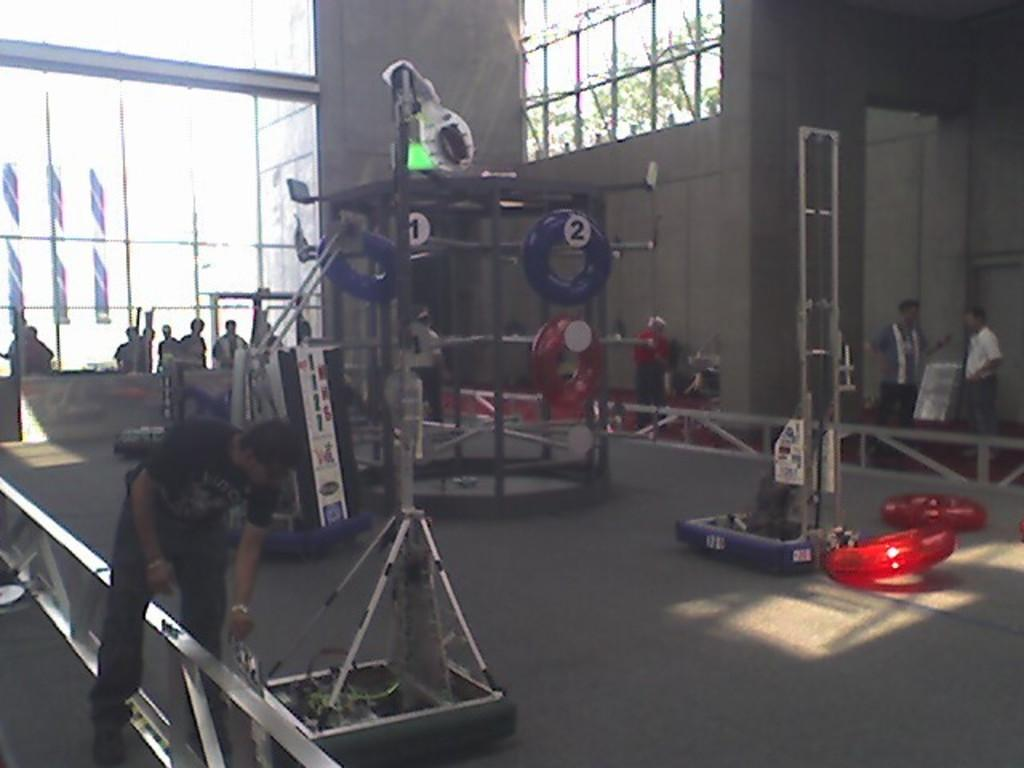Who or what can be seen in the image? There are people in the image. What objects are hanging on a rod in the image? Swimming tubes are hanging on a rod in the image. What can be seen in the background of the image? There are windows visible in the background of the image. What type of business is being conducted in the image? There is no indication of a business being conducted in the image; it primarily features people and swimming tubes. 